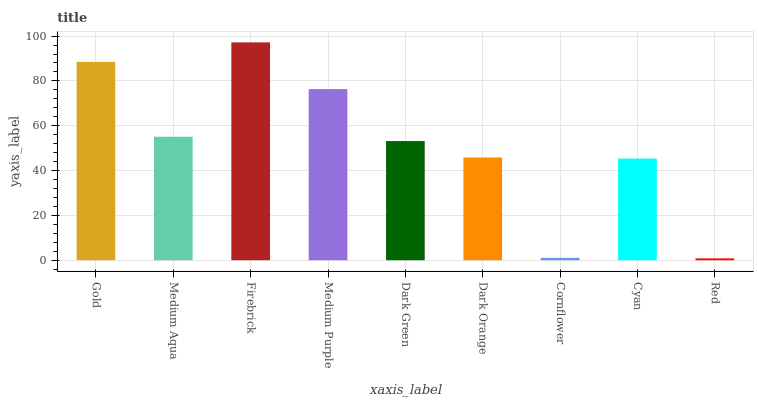Is Medium Aqua the minimum?
Answer yes or no. No. Is Medium Aqua the maximum?
Answer yes or no. No. Is Gold greater than Medium Aqua?
Answer yes or no. Yes. Is Medium Aqua less than Gold?
Answer yes or no. Yes. Is Medium Aqua greater than Gold?
Answer yes or no. No. Is Gold less than Medium Aqua?
Answer yes or no. No. Is Dark Green the high median?
Answer yes or no. Yes. Is Dark Green the low median?
Answer yes or no. Yes. Is Medium Aqua the high median?
Answer yes or no. No. Is Gold the low median?
Answer yes or no. No. 